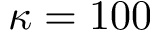<formula> <loc_0><loc_0><loc_500><loc_500>\kappa = 1 0 0</formula> 